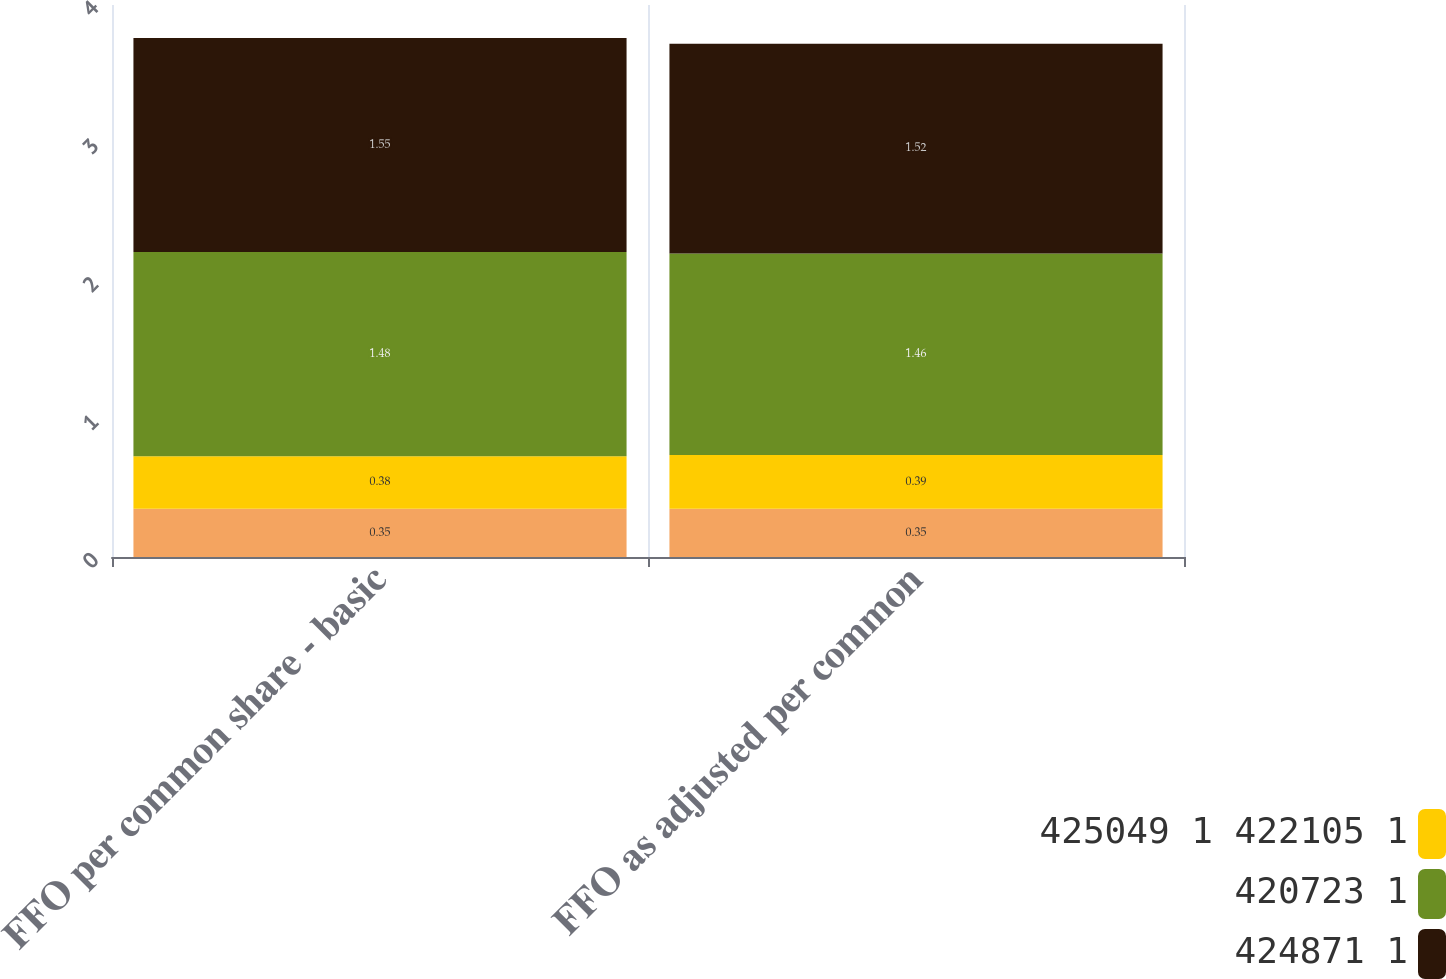Convert chart to OTSL. <chart><loc_0><loc_0><loc_500><loc_500><stacked_bar_chart><ecel><fcel>FFO per common share - basic<fcel>FFO as adjusted per common<nl><fcel>nan<fcel>0.35<fcel>0.35<nl><fcel>425049 1 422105 1<fcel>0.38<fcel>0.39<nl><fcel>420723 1<fcel>1.48<fcel>1.46<nl><fcel>424871 1<fcel>1.55<fcel>1.52<nl></chart> 